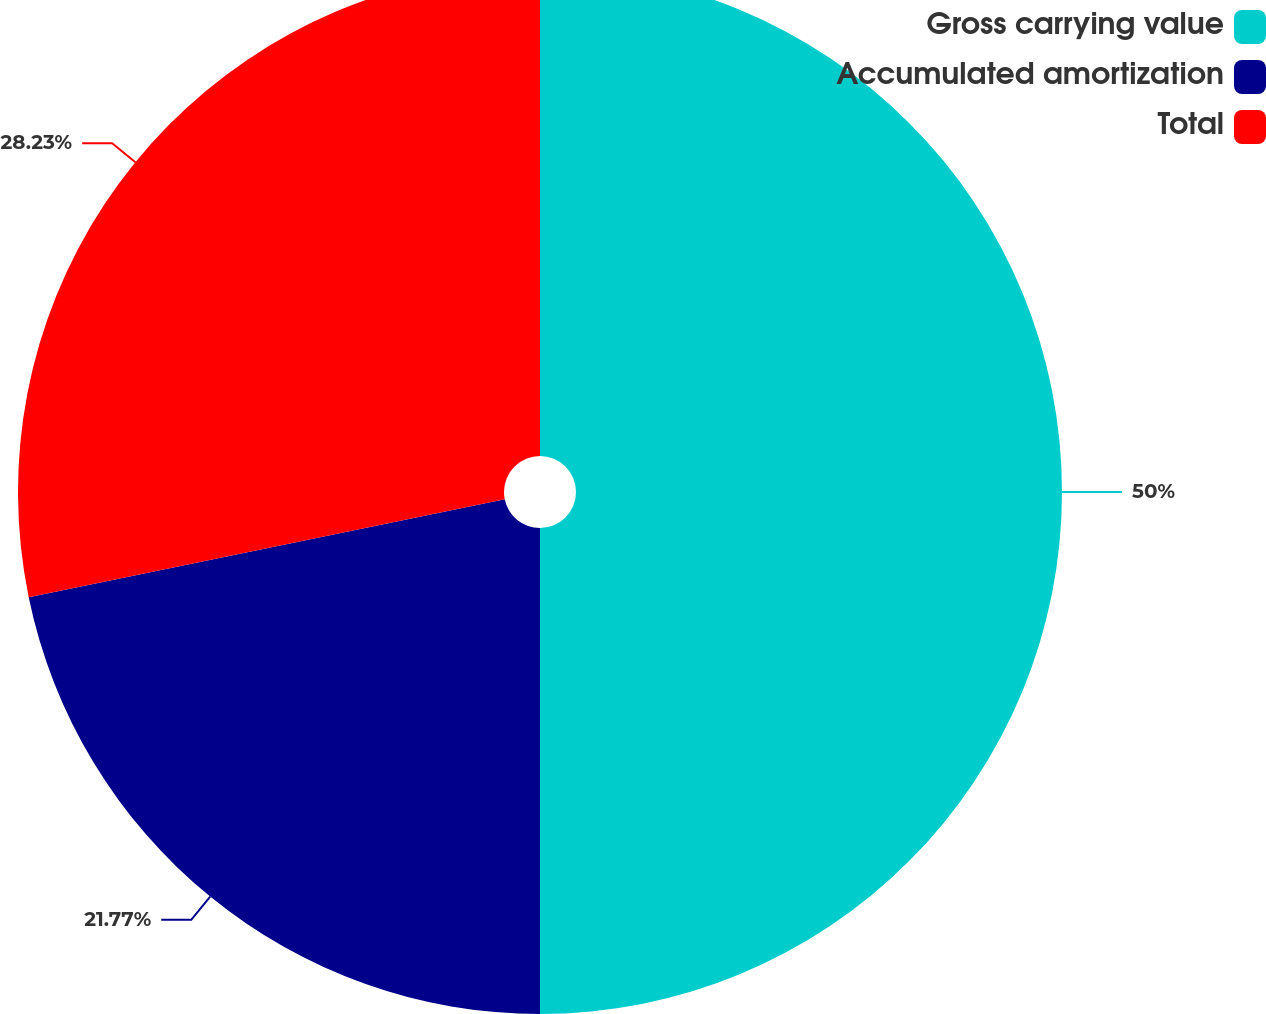Convert chart to OTSL. <chart><loc_0><loc_0><loc_500><loc_500><pie_chart><fcel>Gross carrying value<fcel>Accumulated amortization<fcel>Total<nl><fcel>50.0%<fcel>21.77%<fcel>28.23%<nl></chart> 